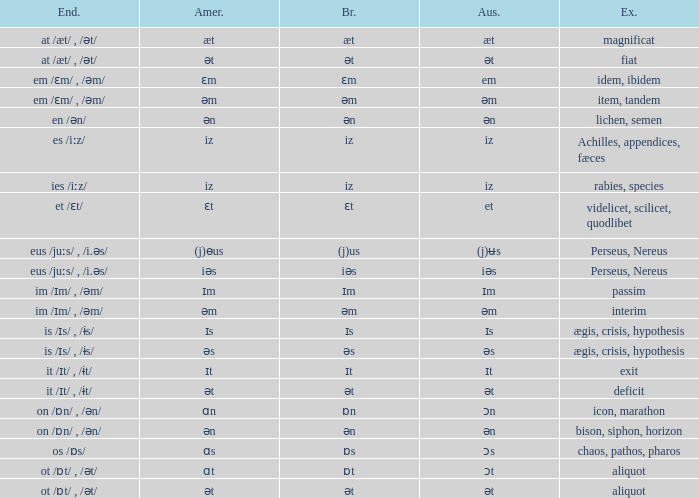Which American has British of ɛm? Ɛm. 